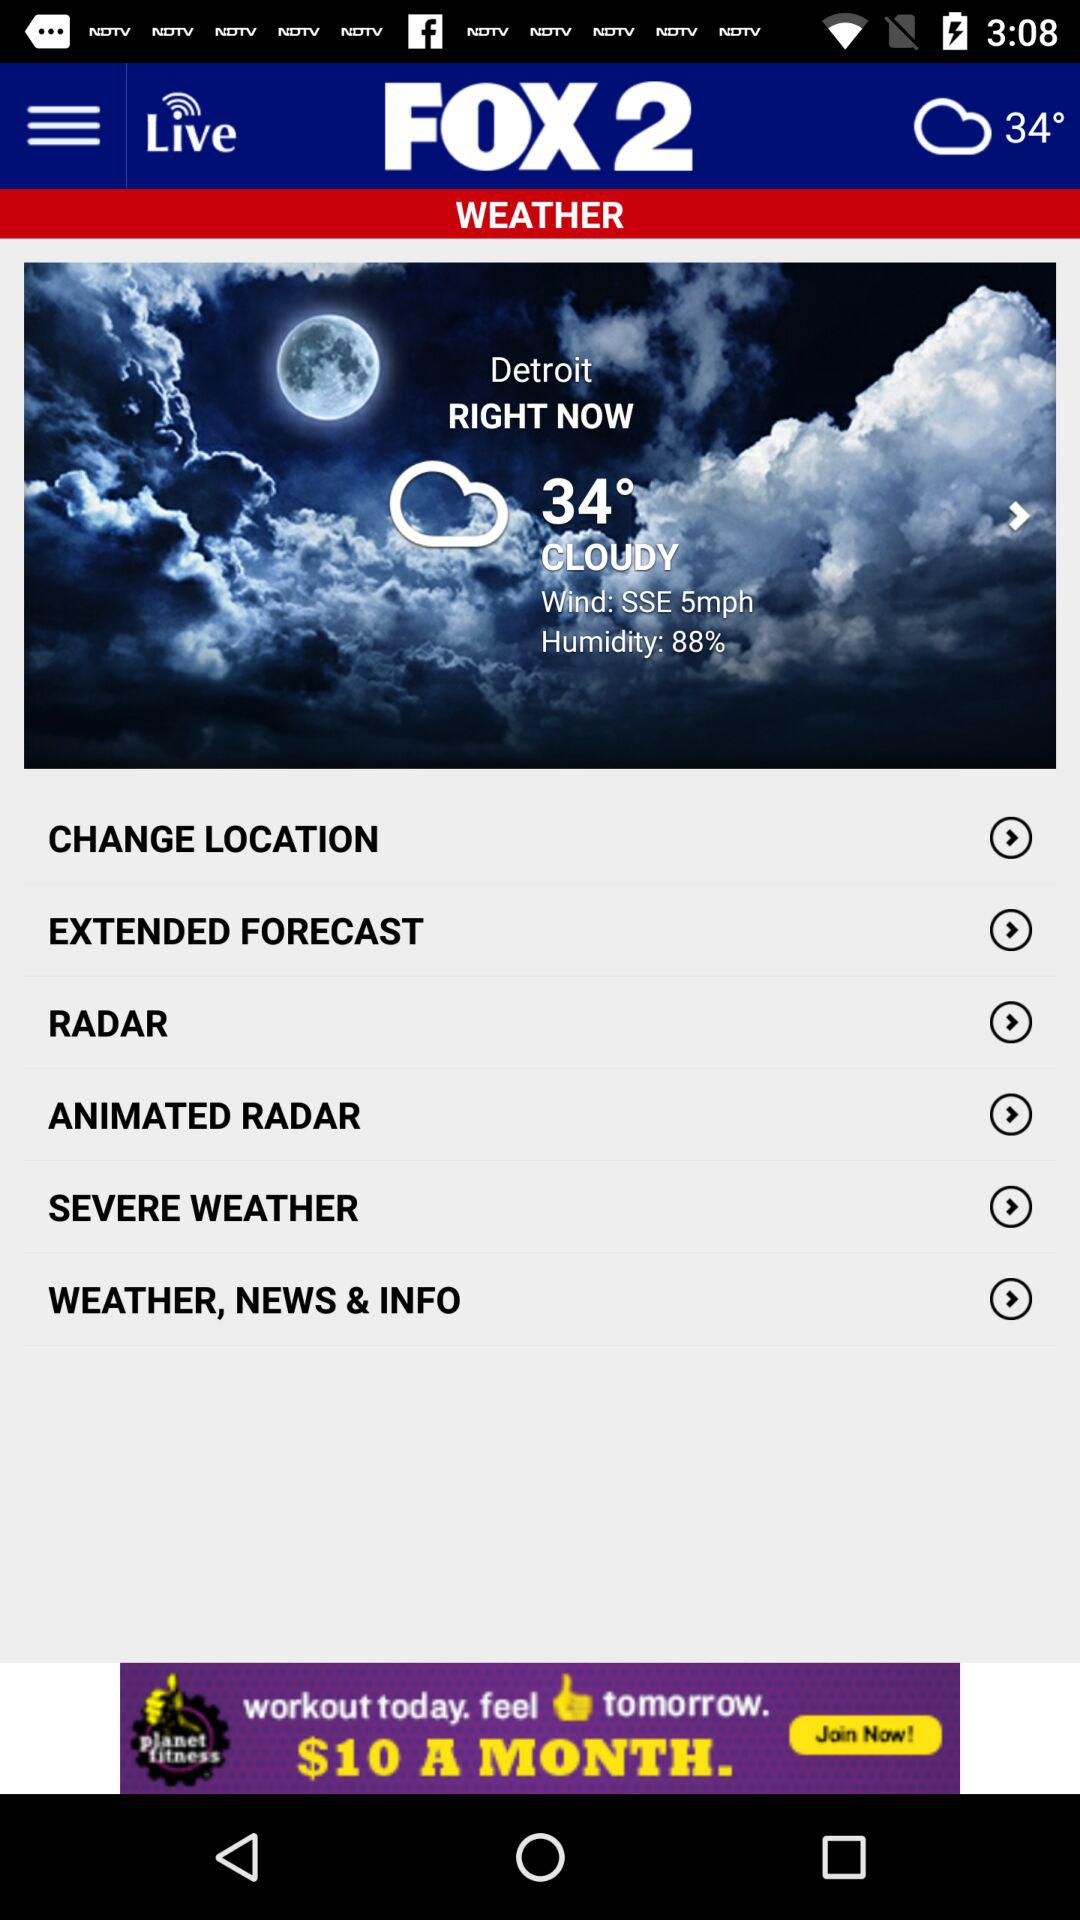What is the humidity? The humidity is 88%. 